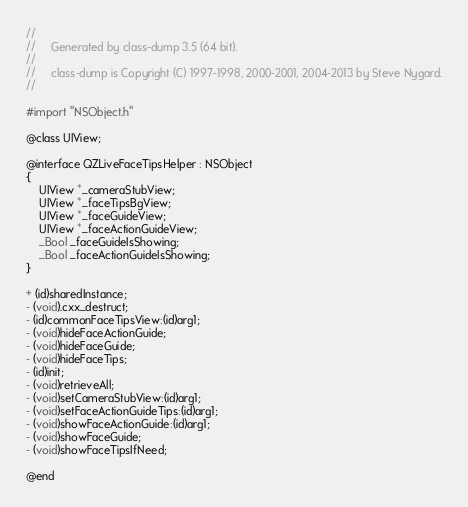<code> <loc_0><loc_0><loc_500><loc_500><_C_>//
//     Generated by class-dump 3.5 (64 bit).
//
//     class-dump is Copyright (C) 1997-1998, 2000-2001, 2004-2013 by Steve Nygard.
//

#import "NSObject.h"

@class UIView;

@interface QZLiveFaceTipsHelper : NSObject
{
    UIView *_cameraStubView;
    UIView *_faceTipsBgView;
    UIView *_faceGuideView;
    UIView *_faceActionGuideView;
    _Bool _faceGuideIsShowing;
    _Bool _faceActionGuideIsShowing;
}

+ (id)sharedInstance;
- (void).cxx_destruct;
- (id)commonFaceTipsView:(id)arg1;
- (void)hideFaceActionGuide;
- (void)hideFaceGuide;
- (void)hideFaceTips;
- (id)init;
- (void)retrieveAll;
- (void)setCameraStubView:(id)arg1;
- (void)setFaceActionGuideTips:(id)arg1;
- (void)showFaceActionGuide:(id)arg1;
- (void)showFaceGuide;
- (void)showFaceTipsIfNeed;

@end

</code> 